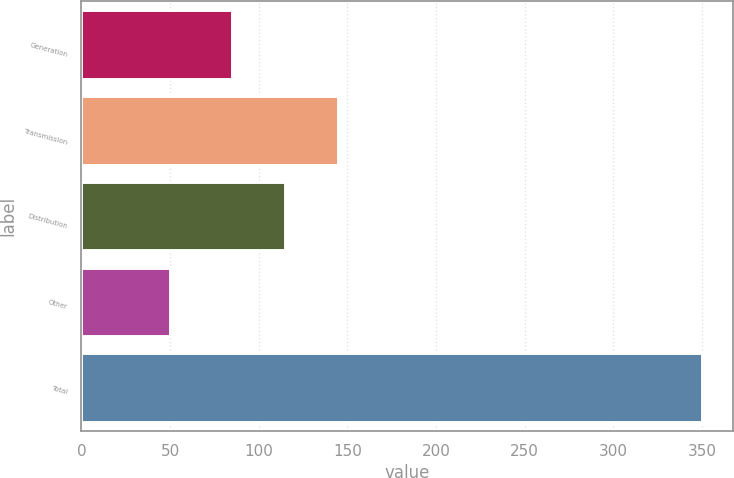Convert chart to OTSL. <chart><loc_0><loc_0><loc_500><loc_500><bar_chart><fcel>Generation<fcel>Transmission<fcel>Distribution<fcel>Other<fcel>Total<nl><fcel>85<fcel>145<fcel>115<fcel>50<fcel>350<nl></chart> 